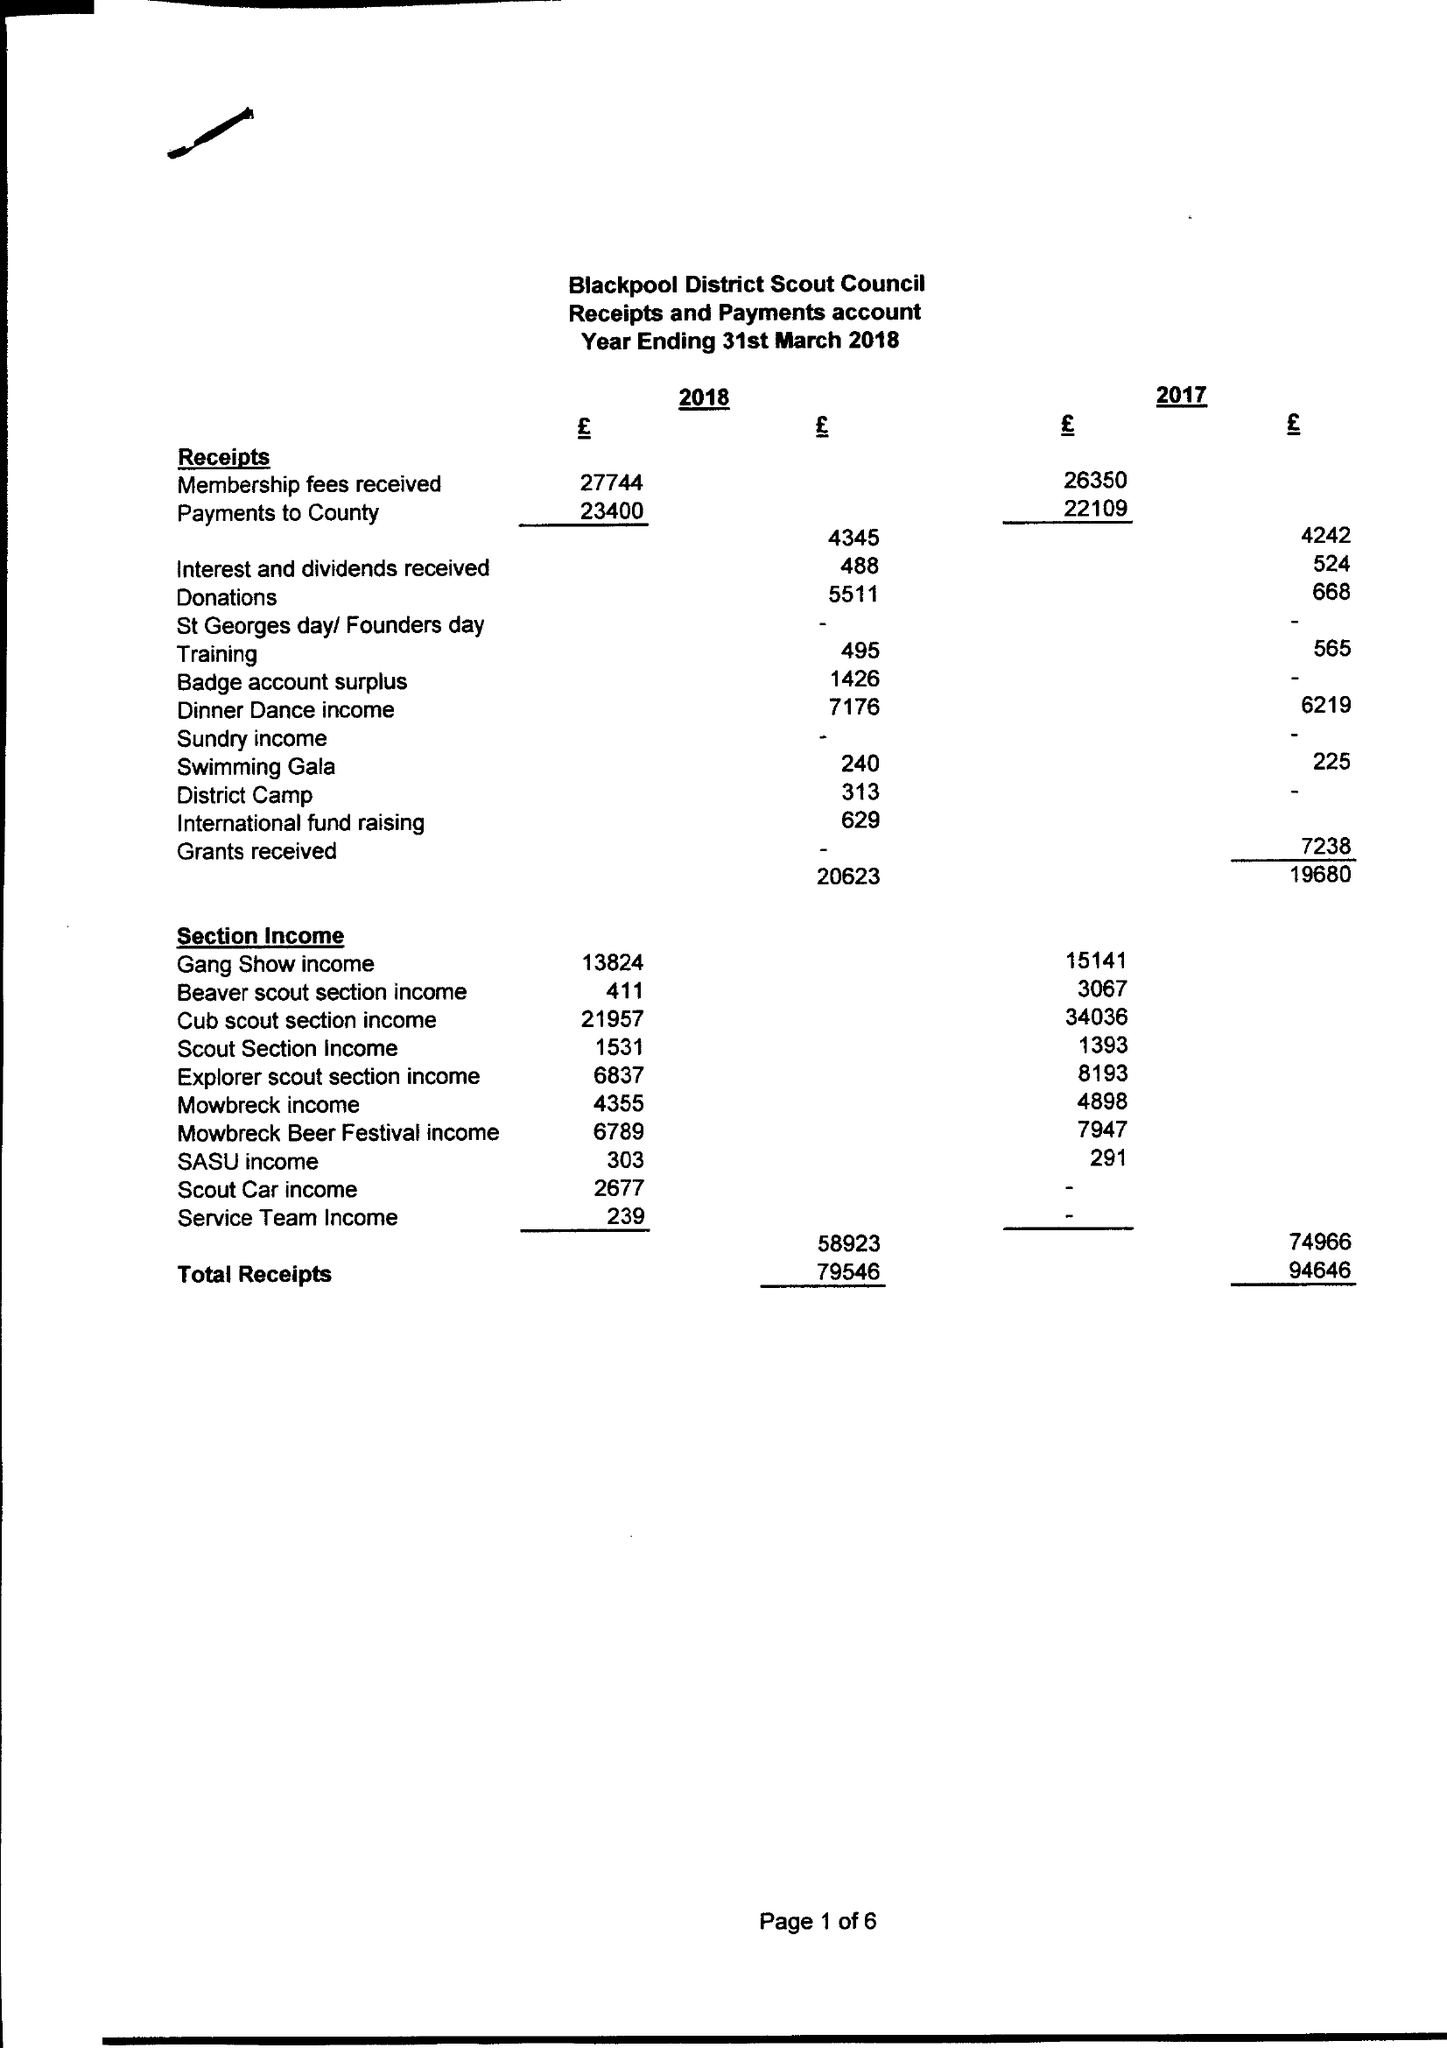What is the value for the charity_number?
Answer the question using a single word or phrase. 521534 